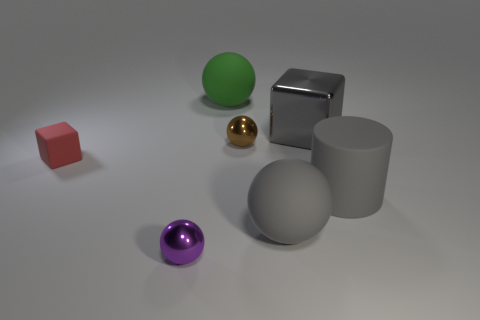Does the matte ball that is in front of the tiny rubber cube have the same color as the big rubber cylinder?
Your answer should be compact. Yes. What number of things are either cubes that are on the left side of the brown ball or brown things that are to the left of the gray metallic cube?
Provide a short and direct response. 2. What is the shape of the purple shiny object?
Provide a short and direct response. Sphere. The matte thing that is the same color as the large cylinder is what shape?
Give a very brief answer. Sphere. What number of small brown cylinders are made of the same material as the gray sphere?
Give a very brief answer. 0. What is the color of the tiny matte object?
Make the answer very short. Red. There is a cylinder that is the same size as the metallic block; what color is it?
Offer a terse response. Gray. Are there any cubes that have the same color as the cylinder?
Provide a succinct answer. Yes. Is the shape of the small metal thing that is in front of the small brown metallic sphere the same as the large rubber object that is behind the big metal object?
Your answer should be very brief. Yes. There is a metallic thing that is the same color as the big rubber cylinder; what size is it?
Make the answer very short. Large. 